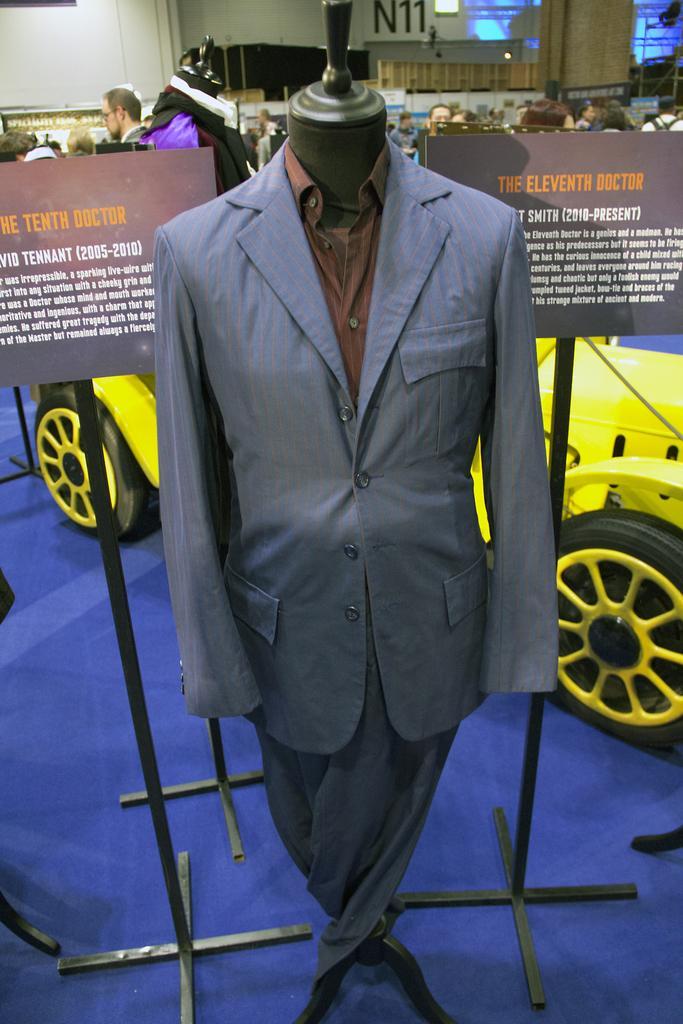Please provide a concise description of this image. In this image we can see clothes on a mannequin. There are boards, stands, and a vehicle. In the background we can see people, wall, boards, and lights. 